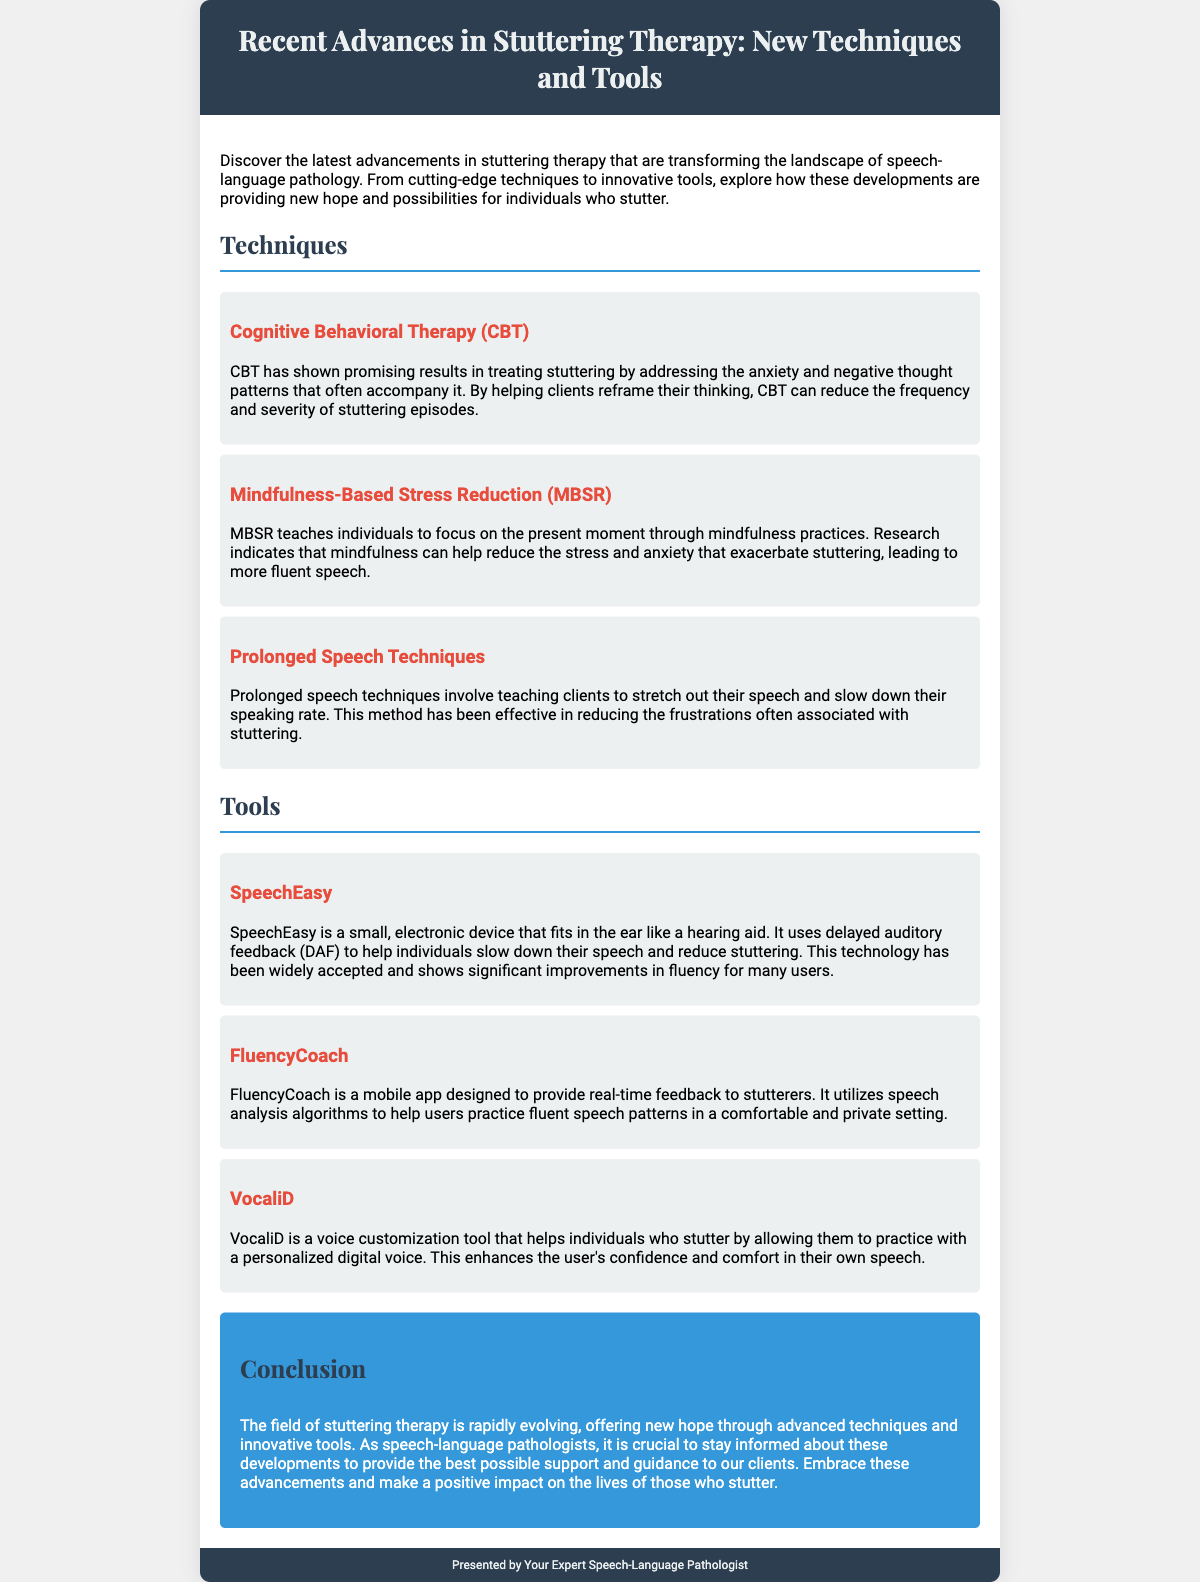What are the three techniques mentioned? The document lists three techniques for stuttering therapy under the "Techniques" section.
Answer: Cognitive Behavioral Therapy, Mindfulness-Based Stress Reduction, Prolonged Speech Techniques What kind of device is SpeechEasy? SpeechEasy is described as a small electronic device that fits in the ear like a hearing aid.
Answer: Electronic device What does FluencyCoach provide? FluencyCoach is designed to provide real-time feedback to stutterers.
Answer: Real-time feedback Which technique helps with anxiety associated with stuttering? Cognitive Behavioral Therapy (CBT) is specifically mentioned as addressing anxiety and negative thought patterns.
Answer: Cognitive Behavioral Therapy What is a characteristic feature of VocaliD? VocaliD allows individuals to practice with a personalized digital voice.
Answer: Personalized digital voice How does MBSR help individuals? Mindfulness-Based Stress Reduction (MBSR) helps reduce stress and anxiety that exacerbate stuttering.
Answer: Reduce stress and anxiety What is the color of the header background? The header background color as stated in the document is dark blue.
Answer: Dark blue What is the main purpose of this Playbill? The Playbill aims to inform about the latest advancements in stuttering therapy.
Answer: Inform about advancements 